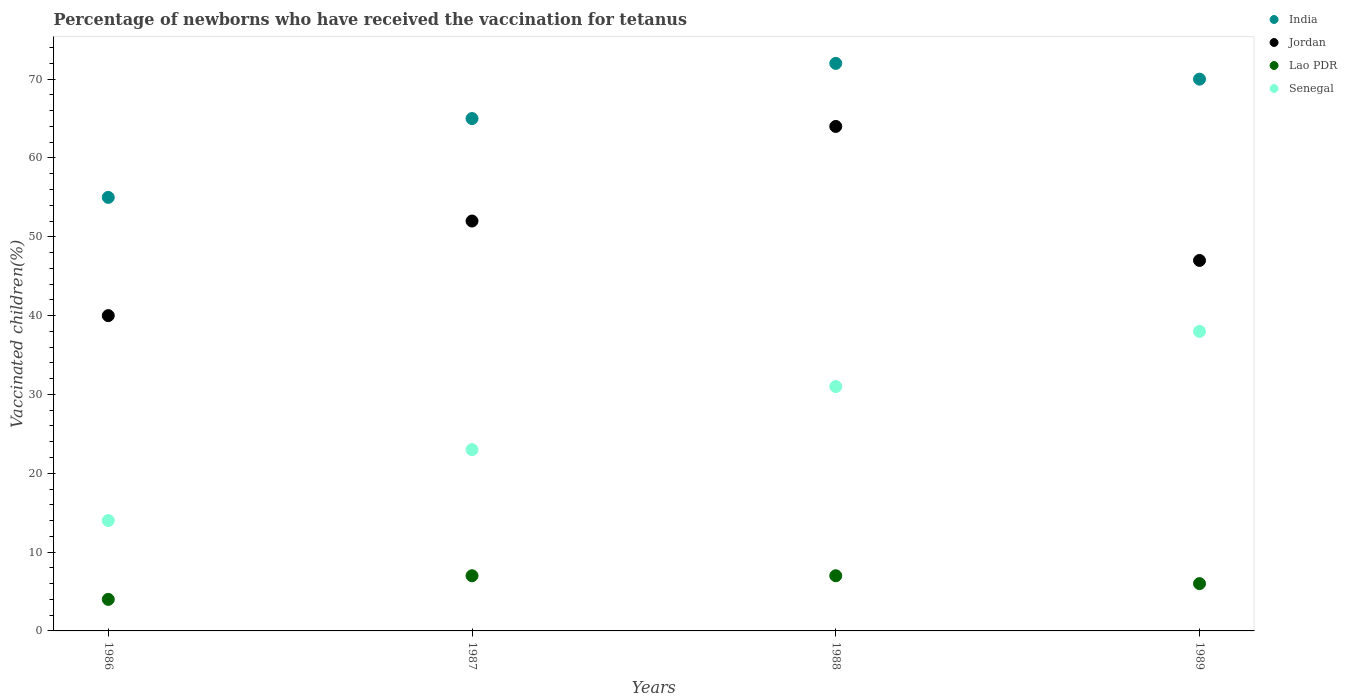How many different coloured dotlines are there?
Provide a short and direct response. 4. Is the number of dotlines equal to the number of legend labels?
Provide a succinct answer. Yes. What is the percentage of vaccinated children in India in 1988?
Offer a terse response. 72. Across all years, what is the maximum percentage of vaccinated children in Lao PDR?
Offer a very short reply. 7. Across all years, what is the minimum percentage of vaccinated children in India?
Your response must be concise. 55. In which year was the percentage of vaccinated children in Jordan maximum?
Provide a succinct answer. 1988. What is the total percentage of vaccinated children in Senegal in the graph?
Your answer should be compact. 106. What is the average percentage of vaccinated children in India per year?
Your response must be concise. 65.5. In the year 1988, what is the difference between the percentage of vaccinated children in Lao PDR and percentage of vaccinated children in Jordan?
Provide a succinct answer. -57. In how many years, is the percentage of vaccinated children in Senegal greater than 40 %?
Your answer should be compact. 0. What is the ratio of the percentage of vaccinated children in Senegal in 1988 to that in 1989?
Give a very brief answer. 0.82. Is the percentage of vaccinated children in Lao PDR in 1986 less than that in 1987?
Ensure brevity in your answer.  Yes. Is the difference between the percentage of vaccinated children in Lao PDR in 1986 and 1988 greater than the difference between the percentage of vaccinated children in Jordan in 1986 and 1988?
Provide a succinct answer. Yes. What is the difference between the highest and the lowest percentage of vaccinated children in Lao PDR?
Ensure brevity in your answer.  3. Is the sum of the percentage of vaccinated children in Lao PDR in 1987 and 1989 greater than the maximum percentage of vaccinated children in India across all years?
Keep it short and to the point. No. Is it the case that in every year, the sum of the percentage of vaccinated children in Senegal and percentage of vaccinated children in Jordan  is greater than the sum of percentage of vaccinated children in Lao PDR and percentage of vaccinated children in India?
Keep it short and to the point. No. Is it the case that in every year, the sum of the percentage of vaccinated children in Lao PDR and percentage of vaccinated children in Jordan  is greater than the percentage of vaccinated children in Senegal?
Provide a succinct answer. Yes. How many dotlines are there?
Provide a succinct answer. 4. How many years are there in the graph?
Your answer should be compact. 4. Does the graph contain any zero values?
Provide a short and direct response. No. Where does the legend appear in the graph?
Your answer should be compact. Top right. How are the legend labels stacked?
Ensure brevity in your answer.  Vertical. What is the title of the graph?
Your answer should be very brief. Percentage of newborns who have received the vaccination for tetanus. Does "Czech Republic" appear as one of the legend labels in the graph?
Offer a terse response. No. What is the label or title of the Y-axis?
Offer a terse response. Vaccinated children(%). What is the Vaccinated children(%) of Senegal in 1986?
Give a very brief answer. 14. What is the Vaccinated children(%) of India in 1987?
Keep it short and to the point. 65. What is the Vaccinated children(%) of Jordan in 1987?
Provide a short and direct response. 52. What is the Vaccinated children(%) of Lao PDR in 1987?
Ensure brevity in your answer.  7. What is the Vaccinated children(%) in Jordan in 1988?
Keep it short and to the point. 64. What is the Vaccinated children(%) of Senegal in 1988?
Provide a short and direct response. 31. What is the Vaccinated children(%) in Lao PDR in 1989?
Make the answer very short. 6. Across all years, what is the maximum Vaccinated children(%) in Jordan?
Offer a very short reply. 64. Across all years, what is the maximum Vaccinated children(%) of Lao PDR?
Your answer should be compact. 7. Across all years, what is the maximum Vaccinated children(%) of Senegal?
Keep it short and to the point. 38. Across all years, what is the minimum Vaccinated children(%) of India?
Make the answer very short. 55. Across all years, what is the minimum Vaccinated children(%) of Jordan?
Give a very brief answer. 40. Across all years, what is the minimum Vaccinated children(%) of Senegal?
Provide a succinct answer. 14. What is the total Vaccinated children(%) of India in the graph?
Give a very brief answer. 262. What is the total Vaccinated children(%) in Jordan in the graph?
Ensure brevity in your answer.  203. What is the total Vaccinated children(%) of Senegal in the graph?
Provide a short and direct response. 106. What is the difference between the Vaccinated children(%) of Jordan in 1986 and that in 1987?
Your answer should be compact. -12. What is the difference between the Vaccinated children(%) in Lao PDR in 1986 and that in 1987?
Offer a terse response. -3. What is the difference between the Vaccinated children(%) of Senegal in 1986 and that in 1987?
Give a very brief answer. -9. What is the difference between the Vaccinated children(%) in Jordan in 1986 and that in 1989?
Your answer should be very brief. -7. What is the difference between the Vaccinated children(%) of Jordan in 1987 and that in 1988?
Offer a very short reply. -12. What is the difference between the Vaccinated children(%) of Lao PDR in 1987 and that in 1988?
Make the answer very short. 0. What is the difference between the Vaccinated children(%) of India in 1987 and that in 1989?
Your answer should be compact. -5. What is the difference between the Vaccinated children(%) in Senegal in 1987 and that in 1989?
Offer a terse response. -15. What is the difference between the Vaccinated children(%) in Jordan in 1988 and that in 1989?
Give a very brief answer. 17. What is the difference between the Vaccinated children(%) in Lao PDR in 1988 and that in 1989?
Keep it short and to the point. 1. What is the difference between the Vaccinated children(%) of Senegal in 1988 and that in 1989?
Offer a terse response. -7. What is the difference between the Vaccinated children(%) in India in 1986 and the Vaccinated children(%) in Jordan in 1987?
Keep it short and to the point. 3. What is the difference between the Vaccinated children(%) in India in 1986 and the Vaccinated children(%) in Lao PDR in 1987?
Your response must be concise. 48. What is the difference between the Vaccinated children(%) in Jordan in 1986 and the Vaccinated children(%) in Lao PDR in 1987?
Your answer should be very brief. 33. What is the difference between the Vaccinated children(%) of Jordan in 1986 and the Vaccinated children(%) of Senegal in 1987?
Your response must be concise. 17. What is the difference between the Vaccinated children(%) of Lao PDR in 1986 and the Vaccinated children(%) of Senegal in 1987?
Your answer should be very brief. -19. What is the difference between the Vaccinated children(%) in Lao PDR in 1986 and the Vaccinated children(%) in Senegal in 1988?
Ensure brevity in your answer.  -27. What is the difference between the Vaccinated children(%) in Lao PDR in 1986 and the Vaccinated children(%) in Senegal in 1989?
Provide a short and direct response. -34. What is the difference between the Vaccinated children(%) in India in 1987 and the Vaccinated children(%) in Jordan in 1988?
Provide a succinct answer. 1. What is the difference between the Vaccinated children(%) of Jordan in 1987 and the Vaccinated children(%) of Lao PDR in 1988?
Your answer should be compact. 45. What is the difference between the Vaccinated children(%) of Jordan in 1987 and the Vaccinated children(%) of Senegal in 1988?
Offer a very short reply. 21. What is the difference between the Vaccinated children(%) in Lao PDR in 1987 and the Vaccinated children(%) in Senegal in 1988?
Keep it short and to the point. -24. What is the difference between the Vaccinated children(%) of India in 1987 and the Vaccinated children(%) of Lao PDR in 1989?
Ensure brevity in your answer.  59. What is the difference between the Vaccinated children(%) in India in 1987 and the Vaccinated children(%) in Senegal in 1989?
Ensure brevity in your answer.  27. What is the difference between the Vaccinated children(%) in Jordan in 1987 and the Vaccinated children(%) in Senegal in 1989?
Your answer should be compact. 14. What is the difference between the Vaccinated children(%) of Lao PDR in 1987 and the Vaccinated children(%) of Senegal in 1989?
Your response must be concise. -31. What is the difference between the Vaccinated children(%) in India in 1988 and the Vaccinated children(%) in Jordan in 1989?
Your answer should be compact. 25. What is the difference between the Vaccinated children(%) in India in 1988 and the Vaccinated children(%) in Lao PDR in 1989?
Provide a short and direct response. 66. What is the difference between the Vaccinated children(%) of Jordan in 1988 and the Vaccinated children(%) of Lao PDR in 1989?
Offer a very short reply. 58. What is the difference between the Vaccinated children(%) in Jordan in 1988 and the Vaccinated children(%) in Senegal in 1989?
Provide a short and direct response. 26. What is the difference between the Vaccinated children(%) of Lao PDR in 1988 and the Vaccinated children(%) of Senegal in 1989?
Make the answer very short. -31. What is the average Vaccinated children(%) of India per year?
Your answer should be compact. 65.5. What is the average Vaccinated children(%) of Jordan per year?
Your response must be concise. 50.75. In the year 1986, what is the difference between the Vaccinated children(%) in India and Vaccinated children(%) in Jordan?
Provide a short and direct response. 15. In the year 1986, what is the difference between the Vaccinated children(%) of India and Vaccinated children(%) of Lao PDR?
Keep it short and to the point. 51. In the year 1986, what is the difference between the Vaccinated children(%) in Jordan and Vaccinated children(%) in Lao PDR?
Your response must be concise. 36. In the year 1987, what is the difference between the Vaccinated children(%) in India and Vaccinated children(%) in Lao PDR?
Keep it short and to the point. 58. In the year 1987, what is the difference between the Vaccinated children(%) in India and Vaccinated children(%) in Senegal?
Provide a short and direct response. 42. In the year 1987, what is the difference between the Vaccinated children(%) in Jordan and Vaccinated children(%) in Senegal?
Your answer should be very brief. 29. In the year 1987, what is the difference between the Vaccinated children(%) of Lao PDR and Vaccinated children(%) of Senegal?
Your answer should be very brief. -16. In the year 1988, what is the difference between the Vaccinated children(%) of India and Vaccinated children(%) of Senegal?
Your answer should be compact. 41. In the year 1988, what is the difference between the Vaccinated children(%) of Jordan and Vaccinated children(%) of Lao PDR?
Keep it short and to the point. 57. In the year 1988, what is the difference between the Vaccinated children(%) in Jordan and Vaccinated children(%) in Senegal?
Keep it short and to the point. 33. In the year 1989, what is the difference between the Vaccinated children(%) in India and Vaccinated children(%) in Jordan?
Keep it short and to the point. 23. In the year 1989, what is the difference between the Vaccinated children(%) of India and Vaccinated children(%) of Lao PDR?
Your response must be concise. 64. In the year 1989, what is the difference between the Vaccinated children(%) in India and Vaccinated children(%) in Senegal?
Make the answer very short. 32. In the year 1989, what is the difference between the Vaccinated children(%) of Lao PDR and Vaccinated children(%) of Senegal?
Your answer should be very brief. -32. What is the ratio of the Vaccinated children(%) in India in 1986 to that in 1987?
Your answer should be very brief. 0.85. What is the ratio of the Vaccinated children(%) in Jordan in 1986 to that in 1987?
Offer a very short reply. 0.77. What is the ratio of the Vaccinated children(%) in Lao PDR in 1986 to that in 1987?
Offer a terse response. 0.57. What is the ratio of the Vaccinated children(%) in Senegal in 1986 to that in 1987?
Keep it short and to the point. 0.61. What is the ratio of the Vaccinated children(%) in India in 1986 to that in 1988?
Offer a terse response. 0.76. What is the ratio of the Vaccinated children(%) in Lao PDR in 1986 to that in 1988?
Your response must be concise. 0.57. What is the ratio of the Vaccinated children(%) of Senegal in 1986 to that in 1988?
Your answer should be very brief. 0.45. What is the ratio of the Vaccinated children(%) in India in 1986 to that in 1989?
Provide a succinct answer. 0.79. What is the ratio of the Vaccinated children(%) in Jordan in 1986 to that in 1989?
Your answer should be very brief. 0.85. What is the ratio of the Vaccinated children(%) of Senegal in 1986 to that in 1989?
Provide a succinct answer. 0.37. What is the ratio of the Vaccinated children(%) in India in 1987 to that in 1988?
Your answer should be very brief. 0.9. What is the ratio of the Vaccinated children(%) in Jordan in 1987 to that in 1988?
Offer a very short reply. 0.81. What is the ratio of the Vaccinated children(%) in Senegal in 1987 to that in 1988?
Your answer should be compact. 0.74. What is the ratio of the Vaccinated children(%) in India in 1987 to that in 1989?
Provide a short and direct response. 0.93. What is the ratio of the Vaccinated children(%) of Jordan in 1987 to that in 1989?
Ensure brevity in your answer.  1.11. What is the ratio of the Vaccinated children(%) of Senegal in 1987 to that in 1989?
Your response must be concise. 0.61. What is the ratio of the Vaccinated children(%) of India in 1988 to that in 1989?
Your answer should be very brief. 1.03. What is the ratio of the Vaccinated children(%) in Jordan in 1988 to that in 1989?
Offer a very short reply. 1.36. What is the ratio of the Vaccinated children(%) in Senegal in 1988 to that in 1989?
Make the answer very short. 0.82. What is the difference between the highest and the second highest Vaccinated children(%) of Lao PDR?
Your answer should be compact. 0. What is the difference between the highest and the lowest Vaccinated children(%) of India?
Give a very brief answer. 17. What is the difference between the highest and the lowest Vaccinated children(%) in Jordan?
Make the answer very short. 24. What is the difference between the highest and the lowest Vaccinated children(%) of Lao PDR?
Offer a terse response. 3. What is the difference between the highest and the lowest Vaccinated children(%) of Senegal?
Ensure brevity in your answer.  24. 